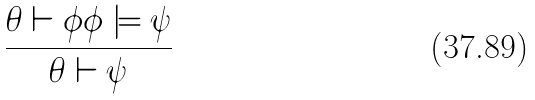<formula> <loc_0><loc_0><loc_500><loc_500>\frac { \theta \vdash \phi \phi \models \psi } { \theta \vdash \psi }</formula> 